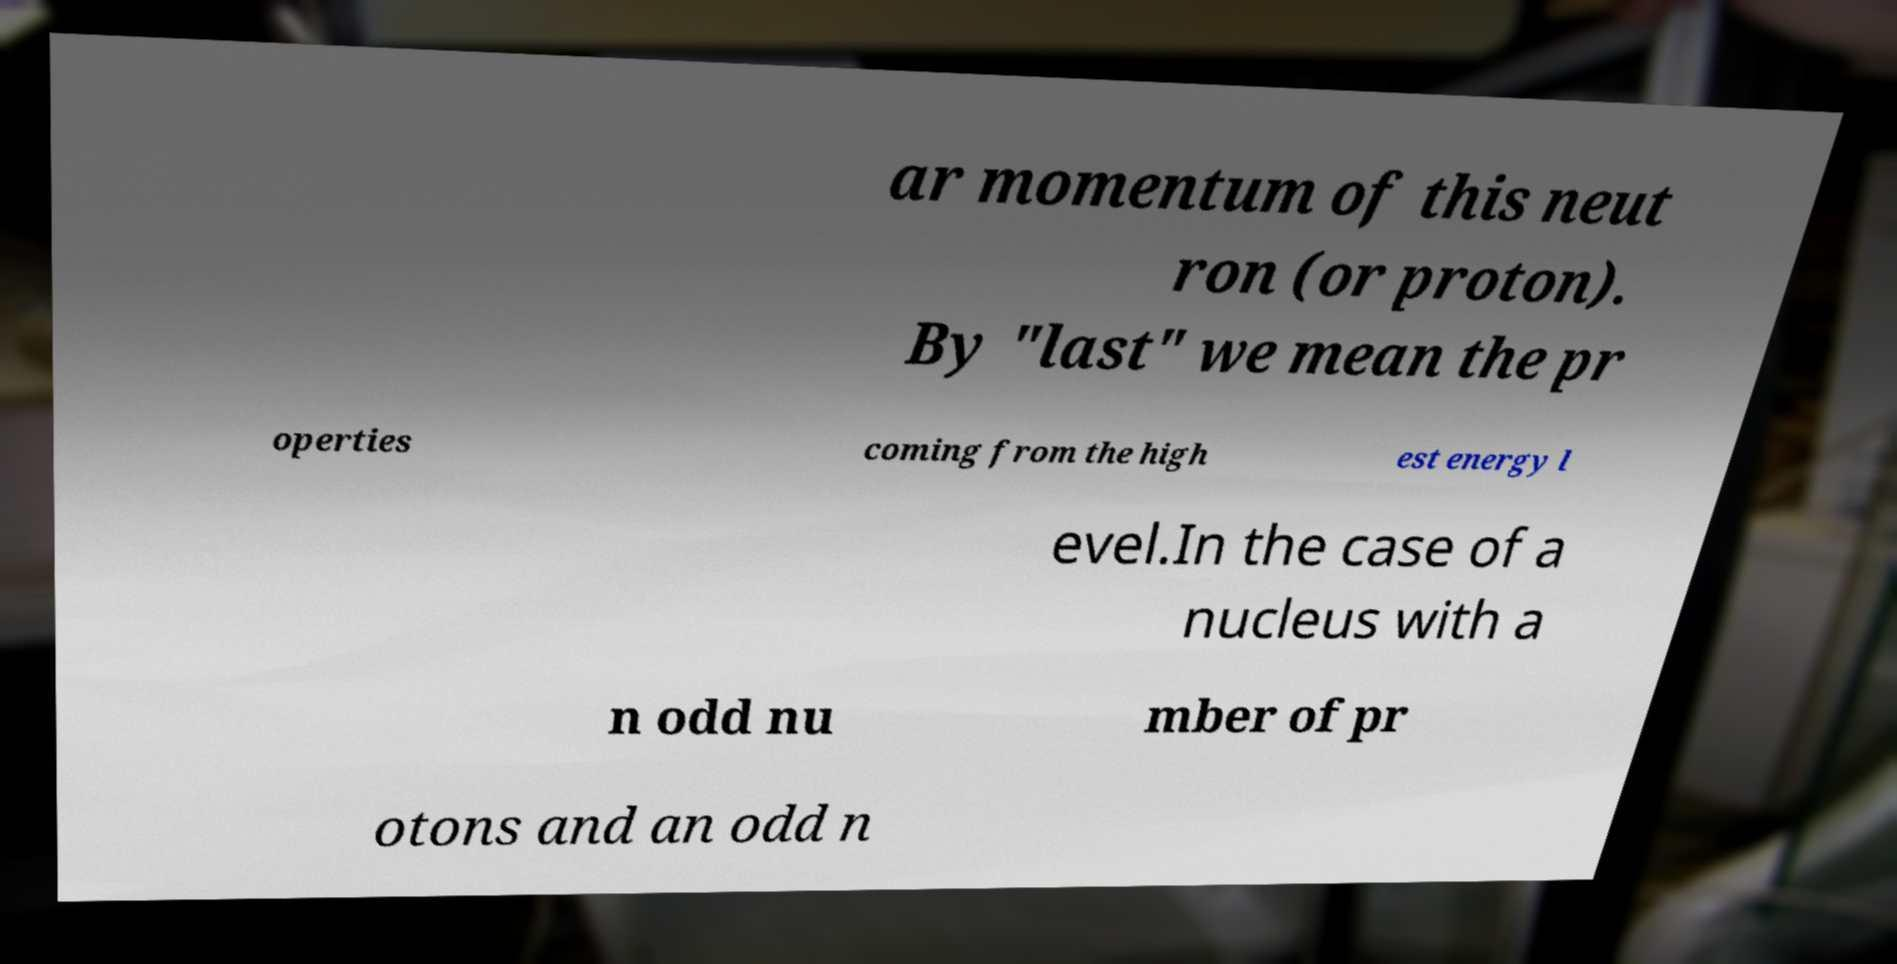Please identify and transcribe the text found in this image. ar momentum of this neut ron (or proton). By "last" we mean the pr operties coming from the high est energy l evel.In the case of a nucleus with a n odd nu mber of pr otons and an odd n 